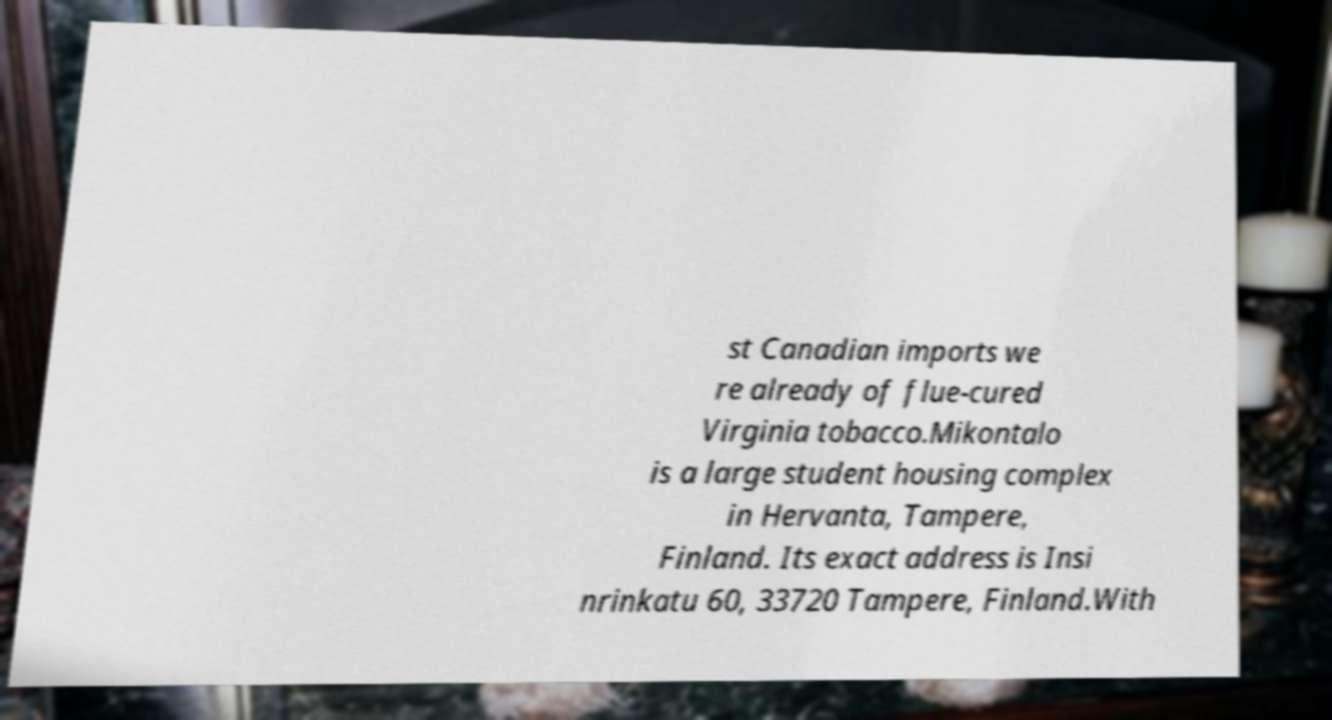I need the written content from this picture converted into text. Can you do that? st Canadian imports we re already of flue-cured Virginia tobacco.Mikontalo is a large student housing complex in Hervanta, Tampere, Finland. Its exact address is Insi nrinkatu 60, 33720 Tampere, Finland.With 